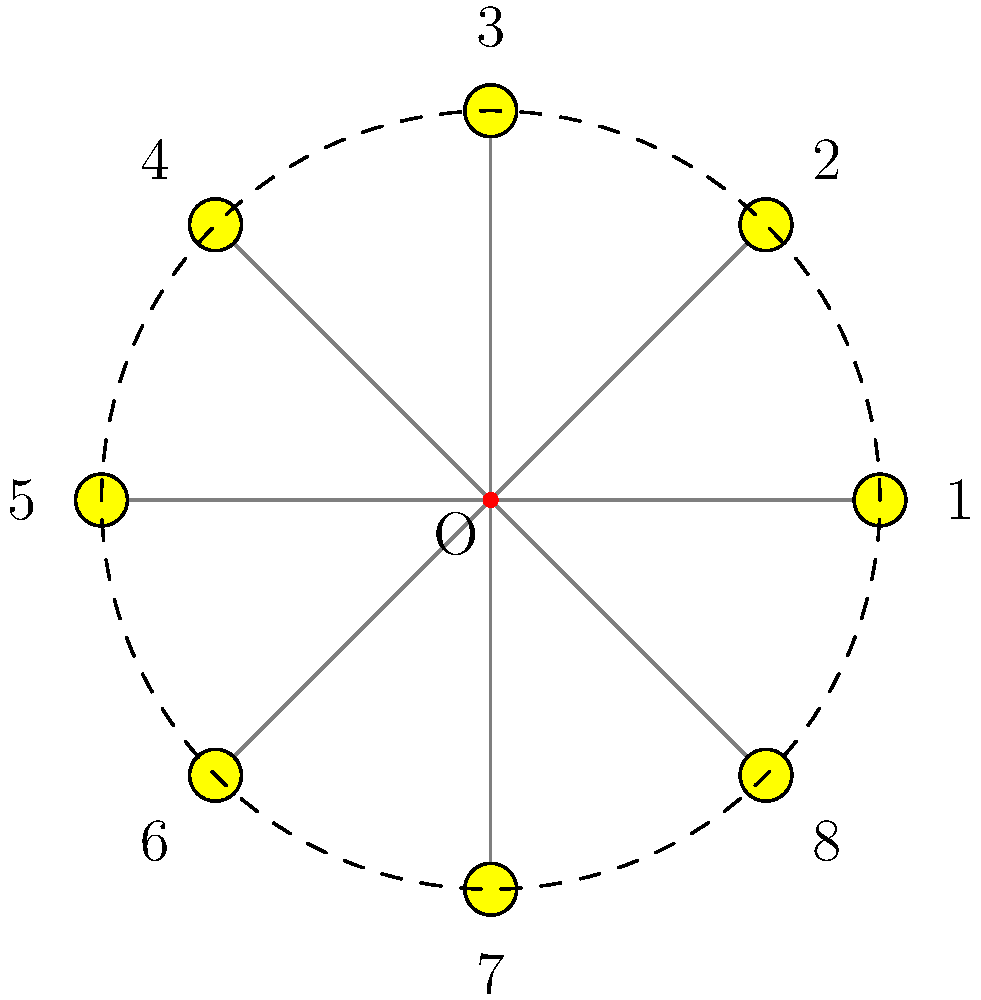For a circular map design, you need to rotate a landmark icon around a fixed point to create a pattern. The icon is initially placed at position 1 and rotated counterclockwise. What is the angle of rotation (in degrees) needed to move the icon from position 1 to position 5? To solve this problem, we need to follow these steps:

1. Understand the circular pattern:
   - The landmark icons are arranged in a circular pattern around a fixed point O.
   - There are 8 equally spaced positions numbered 1 to 8.

2. Calculate the angle between adjacent positions:
   - In a full circle, there are 360°.
   - With 8 positions, the angle between each position is: 360° ÷ 8 = 45°

3. Determine the number of positions between 1 and 5:
   - Moving counterclockwise from 1 to 5, we pass through positions 2, 3, and 4.
   - This means we move through 4 intervals (1 to 2, 2 to 3, 3 to 4, and 4 to 5).

4. Calculate the total rotation angle:
   - Angle of rotation = Number of intervals × Angle between adjacent positions
   - Angle of rotation = 4 × 45° = 180°

Therefore, the angle of rotation needed to move the icon from position 1 to position 5 is 180°.
Answer: 180° 